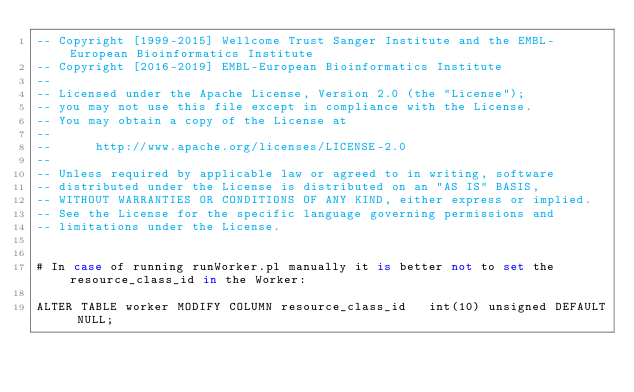<code> <loc_0><loc_0><loc_500><loc_500><_SQL_>-- Copyright [1999-2015] Wellcome Trust Sanger Institute and the EMBL-European Bioinformatics Institute
-- Copyright [2016-2019] EMBL-European Bioinformatics Institute
-- 
-- Licensed under the Apache License, Version 2.0 (the "License");
-- you may not use this file except in compliance with the License.
-- You may obtain a copy of the License at
-- 
--      http://www.apache.org/licenses/LICENSE-2.0
-- 
-- Unless required by applicable law or agreed to in writing, software
-- distributed under the License is distributed on an "AS IS" BASIS,
-- WITHOUT WARRANTIES OR CONDITIONS OF ANY KIND, either express or implied.
-- See the License for the specific language governing permissions and
-- limitations under the License.


# In case of running runWorker.pl manually it is better not to set the resource_class_id in the Worker:

ALTER TABLE worker MODIFY COLUMN resource_class_id   int(10) unsigned DEFAULT NULL;
</code> 